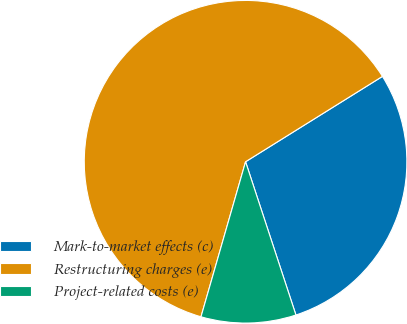Convert chart to OTSL. <chart><loc_0><loc_0><loc_500><loc_500><pie_chart><fcel>Mark-to-market effects (c)<fcel>Restructuring charges (e)<fcel>Project-related costs (e)<nl><fcel>28.82%<fcel>61.67%<fcel>9.51%<nl></chart> 